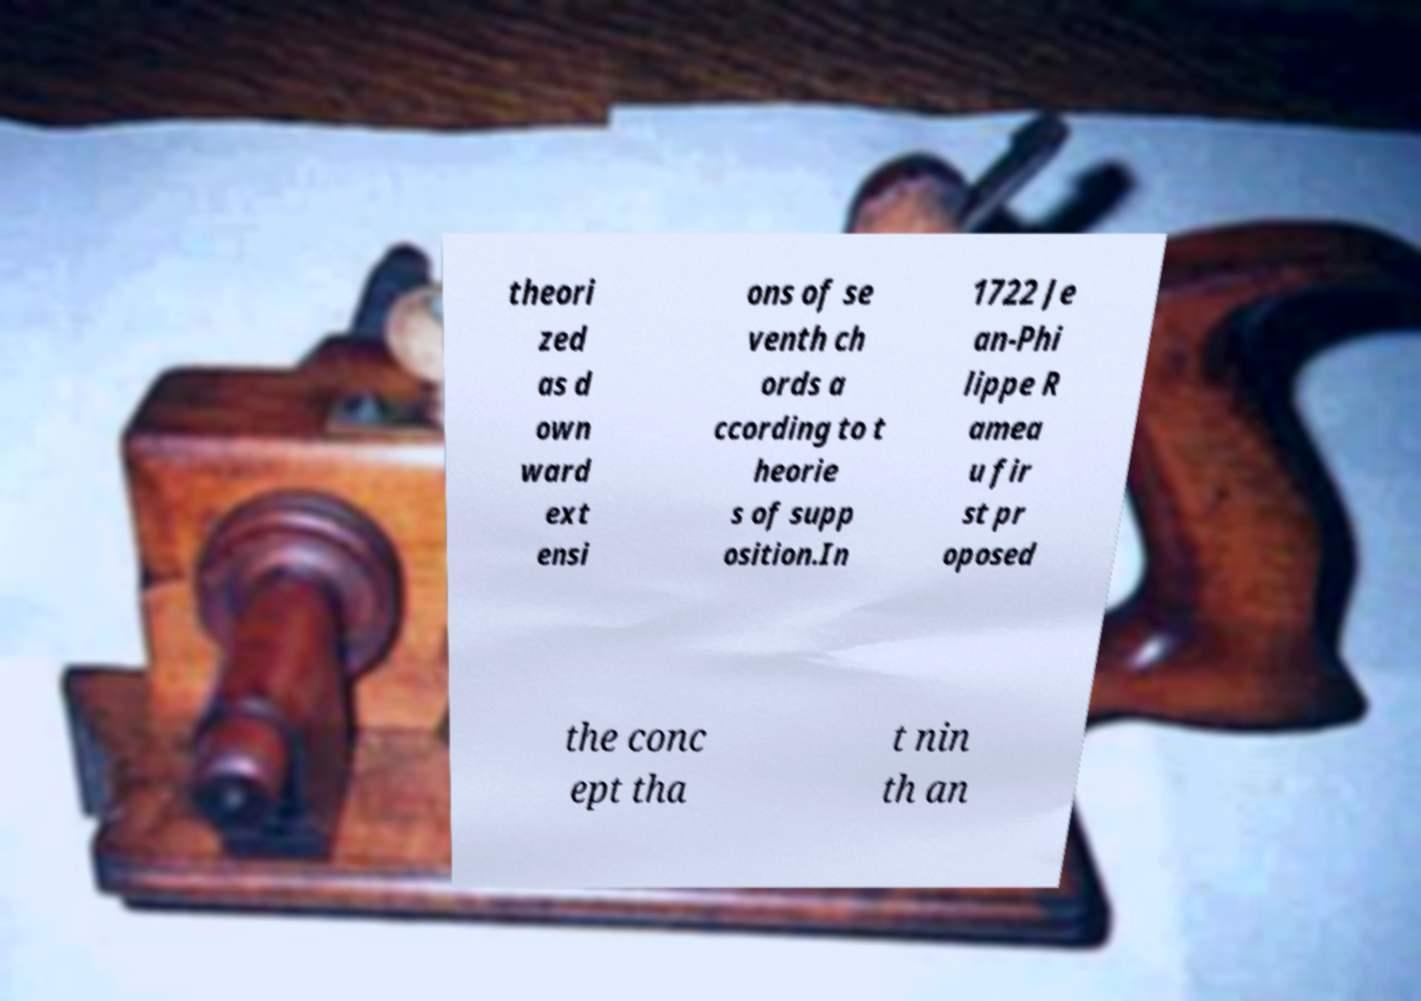There's text embedded in this image that I need extracted. Can you transcribe it verbatim? theori zed as d own ward ext ensi ons of se venth ch ords a ccording to t heorie s of supp osition.In 1722 Je an-Phi lippe R amea u fir st pr oposed the conc ept tha t nin th an 